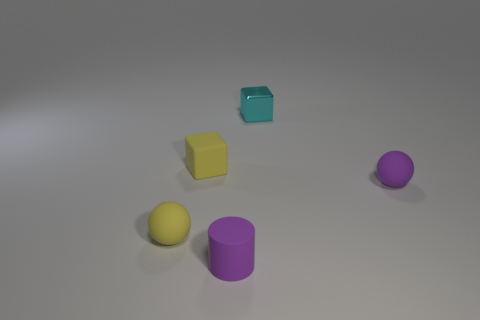Add 4 tiny rubber cubes. How many objects exist? 9 Subtract all cylinders. How many objects are left? 4 Add 5 yellow spheres. How many yellow spheres exist? 6 Subtract 0 cyan spheres. How many objects are left? 5 Subtract all metal things. Subtract all small yellow cubes. How many objects are left? 3 Add 3 yellow matte things. How many yellow matte things are left? 5 